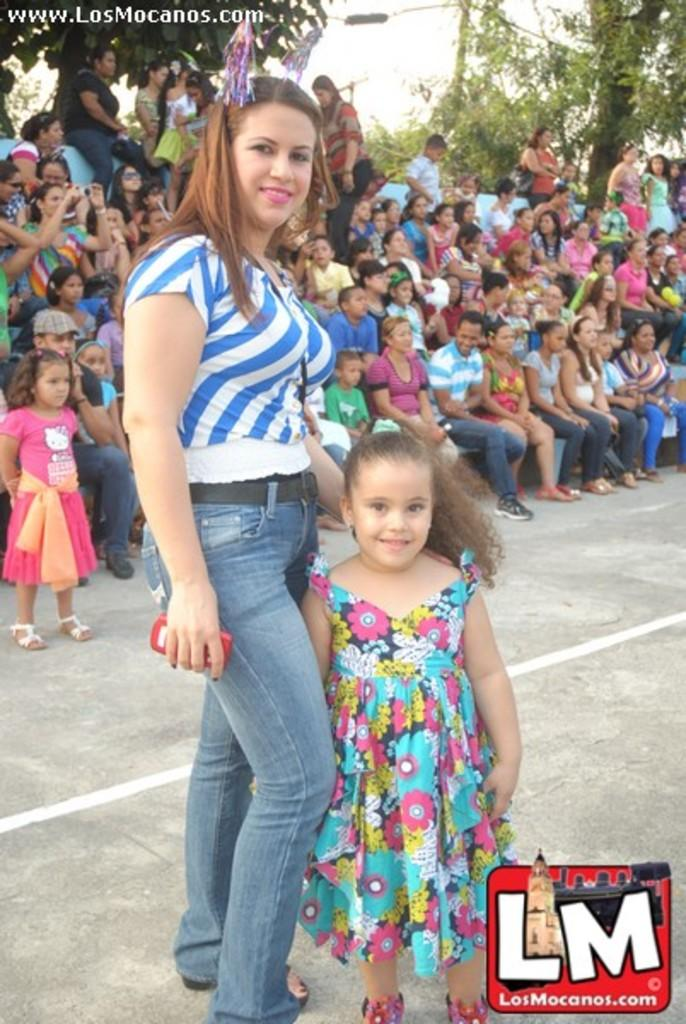What are the people in the front of the image doing? The persons in the front of the image are standing and smiling. What is happening in the background of the image? In the background of the image, there are persons sitting and standing. What type of natural scenery can be seen in the image? There are trees visible in the image. What type of art is the dad creating in the image? There is no dad or art creation present in the image. How many pizzas are visible in the image? There are no pizzas present in the image. 